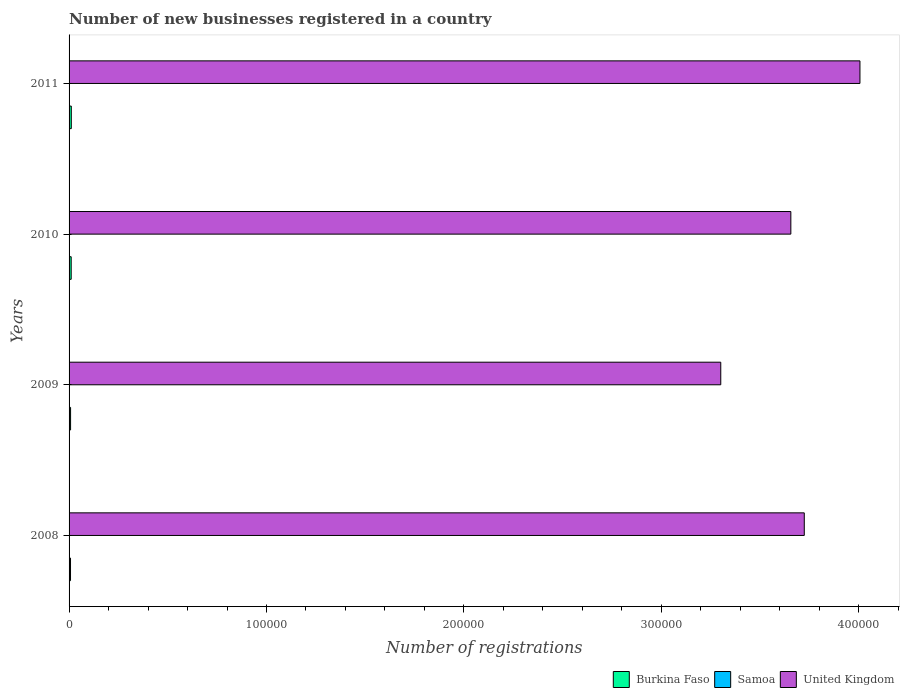Are the number of bars per tick equal to the number of legend labels?
Make the answer very short. Yes. Are the number of bars on each tick of the Y-axis equal?
Provide a succinct answer. Yes. In how many cases, is the number of bars for a given year not equal to the number of legend labels?
Ensure brevity in your answer.  0. What is the number of new businesses registered in United Kingdom in 2011?
Provide a short and direct response. 4.01e+05. Across all years, what is the maximum number of new businesses registered in Burkina Faso?
Your answer should be very brief. 1127. Across all years, what is the minimum number of new businesses registered in Samoa?
Keep it short and to the point. 92. In which year was the number of new businesses registered in Samoa maximum?
Your answer should be very brief. 2011. In which year was the number of new businesses registered in Samoa minimum?
Offer a very short reply. 2008. What is the total number of new businesses registered in Samoa in the graph?
Offer a terse response. 473. What is the difference between the number of new businesses registered in United Kingdom in 2008 and that in 2011?
Give a very brief answer. -2.82e+04. What is the difference between the number of new businesses registered in Burkina Faso in 2010 and the number of new businesses registered in Samoa in 2009?
Provide a short and direct response. 954. What is the average number of new businesses registered in United Kingdom per year?
Your answer should be very brief. 3.67e+05. In the year 2011, what is the difference between the number of new businesses registered in United Kingdom and number of new businesses registered in Burkina Faso?
Provide a succinct answer. 3.99e+05. What is the ratio of the number of new businesses registered in Burkina Faso in 2008 to that in 2010?
Keep it short and to the point. 0.68. Is the number of new businesses registered in United Kingdom in 2009 less than that in 2011?
Offer a terse response. Yes. Is the difference between the number of new businesses registered in United Kingdom in 2008 and 2009 greater than the difference between the number of new businesses registered in Burkina Faso in 2008 and 2009?
Ensure brevity in your answer.  Yes. What does the 2nd bar from the top in 2010 represents?
Ensure brevity in your answer.  Samoa. What does the 2nd bar from the bottom in 2010 represents?
Provide a succinct answer. Samoa. Are the values on the major ticks of X-axis written in scientific E-notation?
Make the answer very short. No. Does the graph contain any zero values?
Make the answer very short. No. Does the graph contain grids?
Your answer should be very brief. No. How are the legend labels stacked?
Make the answer very short. Horizontal. What is the title of the graph?
Offer a terse response. Number of new businesses registered in a country. What is the label or title of the X-axis?
Your answer should be compact. Number of registrations. What is the Number of registrations of Burkina Faso in 2008?
Keep it short and to the point. 730. What is the Number of registrations of Samoa in 2008?
Offer a very short reply. 92. What is the Number of registrations of United Kingdom in 2008?
Provide a succinct answer. 3.72e+05. What is the Number of registrations in Burkina Faso in 2009?
Keep it short and to the point. 766. What is the Number of registrations of Samoa in 2009?
Provide a short and direct response. 122. What is the Number of registrations in United Kingdom in 2009?
Ensure brevity in your answer.  3.30e+05. What is the Number of registrations in Burkina Faso in 2010?
Your response must be concise. 1076. What is the Number of registrations in Samoa in 2010?
Your response must be concise. 126. What is the Number of registrations of United Kingdom in 2010?
Offer a terse response. 3.66e+05. What is the Number of registrations of Burkina Faso in 2011?
Provide a succinct answer. 1127. What is the Number of registrations in Samoa in 2011?
Make the answer very short. 133. What is the Number of registrations in United Kingdom in 2011?
Provide a short and direct response. 4.01e+05. Across all years, what is the maximum Number of registrations in Burkina Faso?
Offer a terse response. 1127. Across all years, what is the maximum Number of registrations of Samoa?
Your response must be concise. 133. Across all years, what is the maximum Number of registrations in United Kingdom?
Give a very brief answer. 4.01e+05. Across all years, what is the minimum Number of registrations in Burkina Faso?
Provide a succinct answer. 730. Across all years, what is the minimum Number of registrations of Samoa?
Give a very brief answer. 92. Across all years, what is the minimum Number of registrations in United Kingdom?
Give a very brief answer. 3.30e+05. What is the total Number of registrations in Burkina Faso in the graph?
Keep it short and to the point. 3699. What is the total Number of registrations in Samoa in the graph?
Offer a very short reply. 473. What is the total Number of registrations of United Kingdom in the graph?
Your response must be concise. 1.47e+06. What is the difference between the Number of registrations of Burkina Faso in 2008 and that in 2009?
Provide a short and direct response. -36. What is the difference between the Number of registrations of United Kingdom in 2008 and that in 2009?
Make the answer very short. 4.23e+04. What is the difference between the Number of registrations in Burkina Faso in 2008 and that in 2010?
Provide a short and direct response. -346. What is the difference between the Number of registrations in Samoa in 2008 and that in 2010?
Provide a short and direct response. -34. What is the difference between the Number of registrations of United Kingdom in 2008 and that in 2010?
Ensure brevity in your answer.  6800. What is the difference between the Number of registrations in Burkina Faso in 2008 and that in 2011?
Offer a terse response. -397. What is the difference between the Number of registrations of Samoa in 2008 and that in 2011?
Ensure brevity in your answer.  -41. What is the difference between the Number of registrations of United Kingdom in 2008 and that in 2011?
Make the answer very short. -2.82e+04. What is the difference between the Number of registrations in Burkina Faso in 2009 and that in 2010?
Offer a very short reply. -310. What is the difference between the Number of registrations in United Kingdom in 2009 and that in 2010?
Give a very brief answer. -3.55e+04. What is the difference between the Number of registrations of Burkina Faso in 2009 and that in 2011?
Provide a succinct answer. -361. What is the difference between the Number of registrations of Samoa in 2009 and that in 2011?
Your response must be concise. -11. What is the difference between the Number of registrations of United Kingdom in 2009 and that in 2011?
Your answer should be compact. -7.05e+04. What is the difference between the Number of registrations of Burkina Faso in 2010 and that in 2011?
Ensure brevity in your answer.  -51. What is the difference between the Number of registrations in United Kingdom in 2010 and that in 2011?
Your answer should be compact. -3.50e+04. What is the difference between the Number of registrations in Burkina Faso in 2008 and the Number of registrations in Samoa in 2009?
Keep it short and to the point. 608. What is the difference between the Number of registrations of Burkina Faso in 2008 and the Number of registrations of United Kingdom in 2009?
Ensure brevity in your answer.  -3.29e+05. What is the difference between the Number of registrations in Samoa in 2008 and the Number of registrations in United Kingdom in 2009?
Provide a succinct answer. -3.30e+05. What is the difference between the Number of registrations in Burkina Faso in 2008 and the Number of registrations in Samoa in 2010?
Provide a succinct answer. 604. What is the difference between the Number of registrations in Burkina Faso in 2008 and the Number of registrations in United Kingdom in 2010?
Your response must be concise. -3.65e+05. What is the difference between the Number of registrations in Samoa in 2008 and the Number of registrations in United Kingdom in 2010?
Provide a short and direct response. -3.66e+05. What is the difference between the Number of registrations in Burkina Faso in 2008 and the Number of registrations in Samoa in 2011?
Your answer should be compact. 597. What is the difference between the Number of registrations of Burkina Faso in 2008 and the Number of registrations of United Kingdom in 2011?
Give a very brief answer. -4.00e+05. What is the difference between the Number of registrations in Samoa in 2008 and the Number of registrations in United Kingdom in 2011?
Ensure brevity in your answer.  -4.01e+05. What is the difference between the Number of registrations of Burkina Faso in 2009 and the Number of registrations of Samoa in 2010?
Your answer should be very brief. 640. What is the difference between the Number of registrations of Burkina Faso in 2009 and the Number of registrations of United Kingdom in 2010?
Make the answer very short. -3.65e+05. What is the difference between the Number of registrations of Samoa in 2009 and the Number of registrations of United Kingdom in 2010?
Offer a terse response. -3.65e+05. What is the difference between the Number of registrations of Burkina Faso in 2009 and the Number of registrations of Samoa in 2011?
Provide a short and direct response. 633. What is the difference between the Number of registrations of Burkina Faso in 2009 and the Number of registrations of United Kingdom in 2011?
Make the answer very short. -4.00e+05. What is the difference between the Number of registrations of Samoa in 2009 and the Number of registrations of United Kingdom in 2011?
Offer a very short reply. -4.00e+05. What is the difference between the Number of registrations in Burkina Faso in 2010 and the Number of registrations in Samoa in 2011?
Offer a terse response. 943. What is the difference between the Number of registrations in Burkina Faso in 2010 and the Number of registrations in United Kingdom in 2011?
Provide a succinct answer. -4.00e+05. What is the difference between the Number of registrations of Samoa in 2010 and the Number of registrations of United Kingdom in 2011?
Provide a short and direct response. -4.00e+05. What is the average Number of registrations in Burkina Faso per year?
Ensure brevity in your answer.  924.75. What is the average Number of registrations in Samoa per year?
Ensure brevity in your answer.  118.25. What is the average Number of registrations in United Kingdom per year?
Ensure brevity in your answer.  3.67e+05. In the year 2008, what is the difference between the Number of registrations in Burkina Faso and Number of registrations in Samoa?
Offer a terse response. 638. In the year 2008, what is the difference between the Number of registrations of Burkina Faso and Number of registrations of United Kingdom?
Give a very brief answer. -3.72e+05. In the year 2008, what is the difference between the Number of registrations in Samoa and Number of registrations in United Kingdom?
Offer a terse response. -3.72e+05. In the year 2009, what is the difference between the Number of registrations of Burkina Faso and Number of registrations of Samoa?
Your answer should be compact. 644. In the year 2009, what is the difference between the Number of registrations of Burkina Faso and Number of registrations of United Kingdom?
Your answer should be very brief. -3.29e+05. In the year 2009, what is the difference between the Number of registrations of Samoa and Number of registrations of United Kingdom?
Provide a succinct answer. -3.30e+05. In the year 2010, what is the difference between the Number of registrations of Burkina Faso and Number of registrations of Samoa?
Provide a short and direct response. 950. In the year 2010, what is the difference between the Number of registrations in Burkina Faso and Number of registrations in United Kingdom?
Offer a very short reply. -3.65e+05. In the year 2010, what is the difference between the Number of registrations in Samoa and Number of registrations in United Kingdom?
Your answer should be compact. -3.65e+05. In the year 2011, what is the difference between the Number of registrations in Burkina Faso and Number of registrations in Samoa?
Your answer should be very brief. 994. In the year 2011, what is the difference between the Number of registrations of Burkina Faso and Number of registrations of United Kingdom?
Make the answer very short. -3.99e+05. In the year 2011, what is the difference between the Number of registrations in Samoa and Number of registrations in United Kingdom?
Make the answer very short. -4.00e+05. What is the ratio of the Number of registrations of Burkina Faso in 2008 to that in 2009?
Make the answer very short. 0.95. What is the ratio of the Number of registrations of Samoa in 2008 to that in 2009?
Give a very brief answer. 0.75. What is the ratio of the Number of registrations in United Kingdom in 2008 to that in 2009?
Provide a succinct answer. 1.13. What is the ratio of the Number of registrations in Burkina Faso in 2008 to that in 2010?
Ensure brevity in your answer.  0.68. What is the ratio of the Number of registrations of Samoa in 2008 to that in 2010?
Make the answer very short. 0.73. What is the ratio of the Number of registrations of United Kingdom in 2008 to that in 2010?
Your answer should be very brief. 1.02. What is the ratio of the Number of registrations in Burkina Faso in 2008 to that in 2011?
Your answer should be very brief. 0.65. What is the ratio of the Number of registrations in Samoa in 2008 to that in 2011?
Your answer should be very brief. 0.69. What is the ratio of the Number of registrations in United Kingdom in 2008 to that in 2011?
Offer a terse response. 0.93. What is the ratio of the Number of registrations of Burkina Faso in 2009 to that in 2010?
Offer a very short reply. 0.71. What is the ratio of the Number of registrations in Samoa in 2009 to that in 2010?
Your answer should be compact. 0.97. What is the ratio of the Number of registrations in United Kingdom in 2009 to that in 2010?
Ensure brevity in your answer.  0.9. What is the ratio of the Number of registrations in Burkina Faso in 2009 to that in 2011?
Your answer should be compact. 0.68. What is the ratio of the Number of registrations in Samoa in 2009 to that in 2011?
Provide a short and direct response. 0.92. What is the ratio of the Number of registrations in United Kingdom in 2009 to that in 2011?
Give a very brief answer. 0.82. What is the ratio of the Number of registrations of Burkina Faso in 2010 to that in 2011?
Keep it short and to the point. 0.95. What is the ratio of the Number of registrations in United Kingdom in 2010 to that in 2011?
Your response must be concise. 0.91. What is the difference between the highest and the second highest Number of registrations in United Kingdom?
Your answer should be very brief. 2.82e+04. What is the difference between the highest and the lowest Number of registrations of Burkina Faso?
Ensure brevity in your answer.  397. What is the difference between the highest and the lowest Number of registrations in Samoa?
Your answer should be very brief. 41. What is the difference between the highest and the lowest Number of registrations of United Kingdom?
Your answer should be very brief. 7.05e+04. 